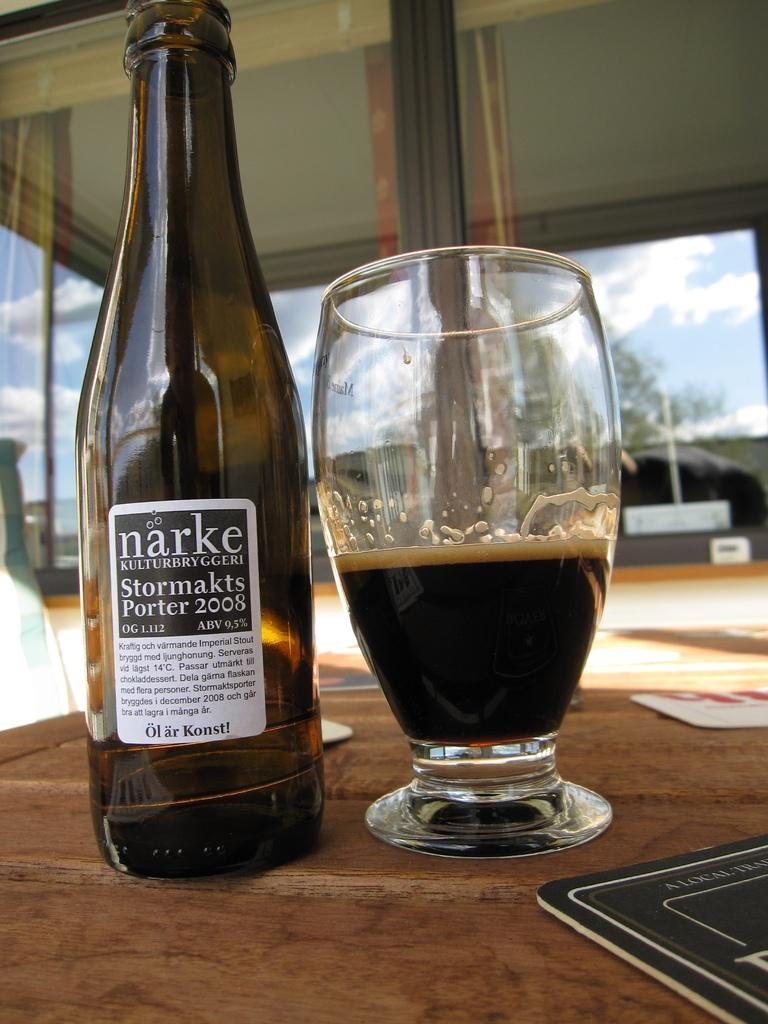<image>
Create a compact narrative representing the image presented. A bottle next to a glass, the bottle bears the words Porter 2008 